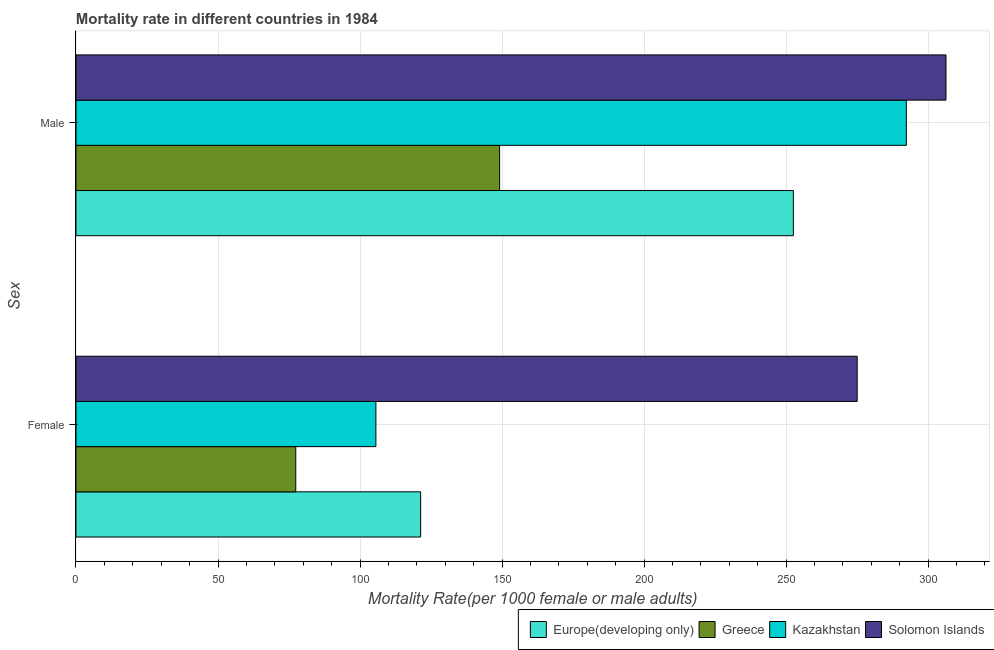How many different coloured bars are there?
Offer a terse response. 4. How many groups of bars are there?
Your answer should be very brief. 2. How many bars are there on the 2nd tick from the bottom?
Provide a succinct answer. 4. What is the label of the 1st group of bars from the top?
Give a very brief answer. Male. What is the male mortality rate in Europe(developing only)?
Provide a short and direct response. 252.57. Across all countries, what is the maximum female mortality rate?
Your response must be concise. 275.05. Across all countries, what is the minimum female mortality rate?
Give a very brief answer. 77.38. In which country was the female mortality rate maximum?
Ensure brevity in your answer.  Solomon Islands. What is the total female mortality rate in the graph?
Keep it short and to the point. 579.36. What is the difference between the female mortality rate in Kazakhstan and that in Europe(developing only)?
Your answer should be compact. -15.75. What is the difference between the male mortality rate in Europe(developing only) and the female mortality rate in Solomon Islands?
Your answer should be very brief. -22.48. What is the average female mortality rate per country?
Your answer should be compact. 144.84. What is the difference between the male mortality rate and female mortality rate in Solomon Islands?
Provide a short and direct response. 31.26. In how many countries, is the male mortality rate greater than 170 ?
Give a very brief answer. 3. What is the ratio of the female mortality rate in Europe(developing only) to that in Kazakhstan?
Keep it short and to the point. 1.15. Is the male mortality rate in Solomon Islands less than that in Kazakhstan?
Offer a terse response. No. In how many countries, is the female mortality rate greater than the average female mortality rate taken over all countries?
Make the answer very short. 1. What does the 3rd bar from the top in Male represents?
Keep it short and to the point. Greece. What does the 4th bar from the bottom in Male represents?
Offer a terse response. Solomon Islands. Are all the bars in the graph horizontal?
Offer a very short reply. Yes. Does the graph contain grids?
Offer a very short reply. Yes. How many legend labels are there?
Provide a succinct answer. 4. How are the legend labels stacked?
Make the answer very short. Horizontal. What is the title of the graph?
Your answer should be very brief. Mortality rate in different countries in 1984. Does "Congo (Democratic)" appear as one of the legend labels in the graph?
Your answer should be compact. No. What is the label or title of the X-axis?
Provide a succinct answer. Mortality Rate(per 1000 female or male adults). What is the label or title of the Y-axis?
Give a very brief answer. Sex. What is the Mortality Rate(per 1000 female or male adults) in Europe(developing only) in Female?
Your answer should be very brief. 121.34. What is the Mortality Rate(per 1000 female or male adults) of Greece in Female?
Your response must be concise. 77.38. What is the Mortality Rate(per 1000 female or male adults) in Kazakhstan in Female?
Give a very brief answer. 105.59. What is the Mortality Rate(per 1000 female or male adults) in Solomon Islands in Female?
Provide a succinct answer. 275.05. What is the Mortality Rate(per 1000 female or male adults) of Europe(developing only) in Male?
Your answer should be very brief. 252.57. What is the Mortality Rate(per 1000 female or male adults) of Greece in Male?
Make the answer very short. 149.15. What is the Mortality Rate(per 1000 female or male adults) of Kazakhstan in Male?
Your answer should be very brief. 292.35. What is the Mortality Rate(per 1000 female or male adults) of Solomon Islands in Male?
Provide a succinct answer. 306.31. Across all Sex, what is the maximum Mortality Rate(per 1000 female or male adults) of Europe(developing only)?
Provide a succinct answer. 252.57. Across all Sex, what is the maximum Mortality Rate(per 1000 female or male adults) of Greece?
Ensure brevity in your answer.  149.15. Across all Sex, what is the maximum Mortality Rate(per 1000 female or male adults) in Kazakhstan?
Make the answer very short. 292.35. Across all Sex, what is the maximum Mortality Rate(per 1000 female or male adults) of Solomon Islands?
Make the answer very short. 306.31. Across all Sex, what is the minimum Mortality Rate(per 1000 female or male adults) of Europe(developing only)?
Give a very brief answer. 121.34. Across all Sex, what is the minimum Mortality Rate(per 1000 female or male adults) of Greece?
Make the answer very short. 77.38. Across all Sex, what is the minimum Mortality Rate(per 1000 female or male adults) in Kazakhstan?
Provide a short and direct response. 105.59. Across all Sex, what is the minimum Mortality Rate(per 1000 female or male adults) of Solomon Islands?
Provide a short and direct response. 275.05. What is the total Mortality Rate(per 1000 female or male adults) in Europe(developing only) in the graph?
Your answer should be compact. 373.91. What is the total Mortality Rate(per 1000 female or male adults) in Greece in the graph?
Provide a short and direct response. 226.53. What is the total Mortality Rate(per 1000 female or male adults) of Kazakhstan in the graph?
Make the answer very short. 397.94. What is the total Mortality Rate(per 1000 female or male adults) of Solomon Islands in the graph?
Ensure brevity in your answer.  581.36. What is the difference between the Mortality Rate(per 1000 female or male adults) in Europe(developing only) in Female and that in Male?
Give a very brief answer. -131.23. What is the difference between the Mortality Rate(per 1000 female or male adults) of Greece in Female and that in Male?
Provide a succinct answer. -71.77. What is the difference between the Mortality Rate(per 1000 female or male adults) of Kazakhstan in Female and that in Male?
Your answer should be very brief. -186.76. What is the difference between the Mortality Rate(per 1000 female or male adults) of Solomon Islands in Female and that in Male?
Provide a succinct answer. -31.26. What is the difference between the Mortality Rate(per 1000 female or male adults) of Europe(developing only) in Female and the Mortality Rate(per 1000 female or male adults) of Greece in Male?
Offer a very short reply. -27.81. What is the difference between the Mortality Rate(per 1000 female or male adults) in Europe(developing only) in Female and the Mortality Rate(per 1000 female or male adults) in Kazakhstan in Male?
Keep it short and to the point. -171.01. What is the difference between the Mortality Rate(per 1000 female or male adults) of Europe(developing only) in Female and the Mortality Rate(per 1000 female or male adults) of Solomon Islands in Male?
Offer a very short reply. -184.97. What is the difference between the Mortality Rate(per 1000 female or male adults) in Greece in Female and the Mortality Rate(per 1000 female or male adults) in Kazakhstan in Male?
Make the answer very short. -214.98. What is the difference between the Mortality Rate(per 1000 female or male adults) in Greece in Female and the Mortality Rate(per 1000 female or male adults) in Solomon Islands in Male?
Offer a terse response. -228.93. What is the difference between the Mortality Rate(per 1000 female or male adults) in Kazakhstan in Female and the Mortality Rate(per 1000 female or male adults) in Solomon Islands in Male?
Offer a very short reply. -200.72. What is the average Mortality Rate(per 1000 female or male adults) of Europe(developing only) per Sex?
Your answer should be very brief. 186.96. What is the average Mortality Rate(per 1000 female or male adults) in Greece per Sex?
Offer a very short reply. 113.26. What is the average Mortality Rate(per 1000 female or male adults) in Kazakhstan per Sex?
Ensure brevity in your answer.  198.97. What is the average Mortality Rate(per 1000 female or male adults) of Solomon Islands per Sex?
Your response must be concise. 290.68. What is the difference between the Mortality Rate(per 1000 female or male adults) in Europe(developing only) and Mortality Rate(per 1000 female or male adults) in Greece in Female?
Ensure brevity in your answer.  43.96. What is the difference between the Mortality Rate(per 1000 female or male adults) of Europe(developing only) and Mortality Rate(per 1000 female or male adults) of Kazakhstan in Female?
Offer a terse response. 15.75. What is the difference between the Mortality Rate(per 1000 female or male adults) of Europe(developing only) and Mortality Rate(per 1000 female or male adults) of Solomon Islands in Female?
Offer a very short reply. -153.71. What is the difference between the Mortality Rate(per 1000 female or male adults) of Greece and Mortality Rate(per 1000 female or male adults) of Kazakhstan in Female?
Make the answer very short. -28.21. What is the difference between the Mortality Rate(per 1000 female or male adults) of Greece and Mortality Rate(per 1000 female or male adults) of Solomon Islands in Female?
Give a very brief answer. -197.67. What is the difference between the Mortality Rate(per 1000 female or male adults) in Kazakhstan and Mortality Rate(per 1000 female or male adults) in Solomon Islands in Female?
Provide a succinct answer. -169.46. What is the difference between the Mortality Rate(per 1000 female or male adults) of Europe(developing only) and Mortality Rate(per 1000 female or male adults) of Greece in Male?
Ensure brevity in your answer.  103.42. What is the difference between the Mortality Rate(per 1000 female or male adults) of Europe(developing only) and Mortality Rate(per 1000 female or male adults) of Kazakhstan in Male?
Give a very brief answer. -39.78. What is the difference between the Mortality Rate(per 1000 female or male adults) of Europe(developing only) and Mortality Rate(per 1000 female or male adults) of Solomon Islands in Male?
Offer a terse response. -53.74. What is the difference between the Mortality Rate(per 1000 female or male adults) in Greece and Mortality Rate(per 1000 female or male adults) in Kazakhstan in Male?
Provide a short and direct response. -143.2. What is the difference between the Mortality Rate(per 1000 female or male adults) of Greece and Mortality Rate(per 1000 female or male adults) of Solomon Islands in Male?
Give a very brief answer. -157.16. What is the difference between the Mortality Rate(per 1000 female or male adults) in Kazakhstan and Mortality Rate(per 1000 female or male adults) in Solomon Islands in Male?
Provide a short and direct response. -13.96. What is the ratio of the Mortality Rate(per 1000 female or male adults) of Europe(developing only) in Female to that in Male?
Keep it short and to the point. 0.48. What is the ratio of the Mortality Rate(per 1000 female or male adults) of Greece in Female to that in Male?
Give a very brief answer. 0.52. What is the ratio of the Mortality Rate(per 1000 female or male adults) in Kazakhstan in Female to that in Male?
Ensure brevity in your answer.  0.36. What is the ratio of the Mortality Rate(per 1000 female or male adults) of Solomon Islands in Female to that in Male?
Your answer should be compact. 0.9. What is the difference between the highest and the second highest Mortality Rate(per 1000 female or male adults) in Europe(developing only)?
Give a very brief answer. 131.23. What is the difference between the highest and the second highest Mortality Rate(per 1000 female or male adults) of Greece?
Your answer should be very brief. 71.77. What is the difference between the highest and the second highest Mortality Rate(per 1000 female or male adults) of Kazakhstan?
Provide a short and direct response. 186.76. What is the difference between the highest and the second highest Mortality Rate(per 1000 female or male adults) of Solomon Islands?
Offer a terse response. 31.26. What is the difference between the highest and the lowest Mortality Rate(per 1000 female or male adults) in Europe(developing only)?
Offer a very short reply. 131.23. What is the difference between the highest and the lowest Mortality Rate(per 1000 female or male adults) of Greece?
Offer a terse response. 71.77. What is the difference between the highest and the lowest Mortality Rate(per 1000 female or male adults) in Kazakhstan?
Provide a short and direct response. 186.76. What is the difference between the highest and the lowest Mortality Rate(per 1000 female or male adults) of Solomon Islands?
Offer a very short reply. 31.26. 